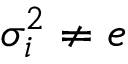Convert formula to latex. <formula><loc_0><loc_0><loc_500><loc_500>\sigma _ { i } ^ { 2 } \neq e</formula> 